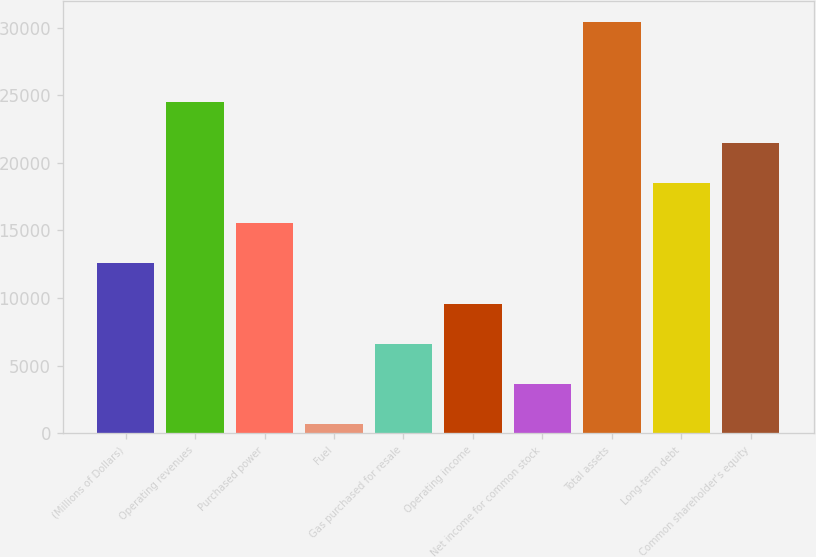<chart> <loc_0><loc_0><loc_500><loc_500><bar_chart><fcel>(Millions of Dollars)<fcel>Operating revenues<fcel>Purchased power<fcel>Fuel<fcel>Gas purchased for resale<fcel>Operating income<fcel>Net income for common stock<fcel>Total assets<fcel>Long-term debt<fcel>Common shareholder's equity<nl><fcel>12562<fcel>24464<fcel>15537.5<fcel>660<fcel>6611<fcel>9586.5<fcel>3635.5<fcel>30415<fcel>18513<fcel>21488.5<nl></chart> 